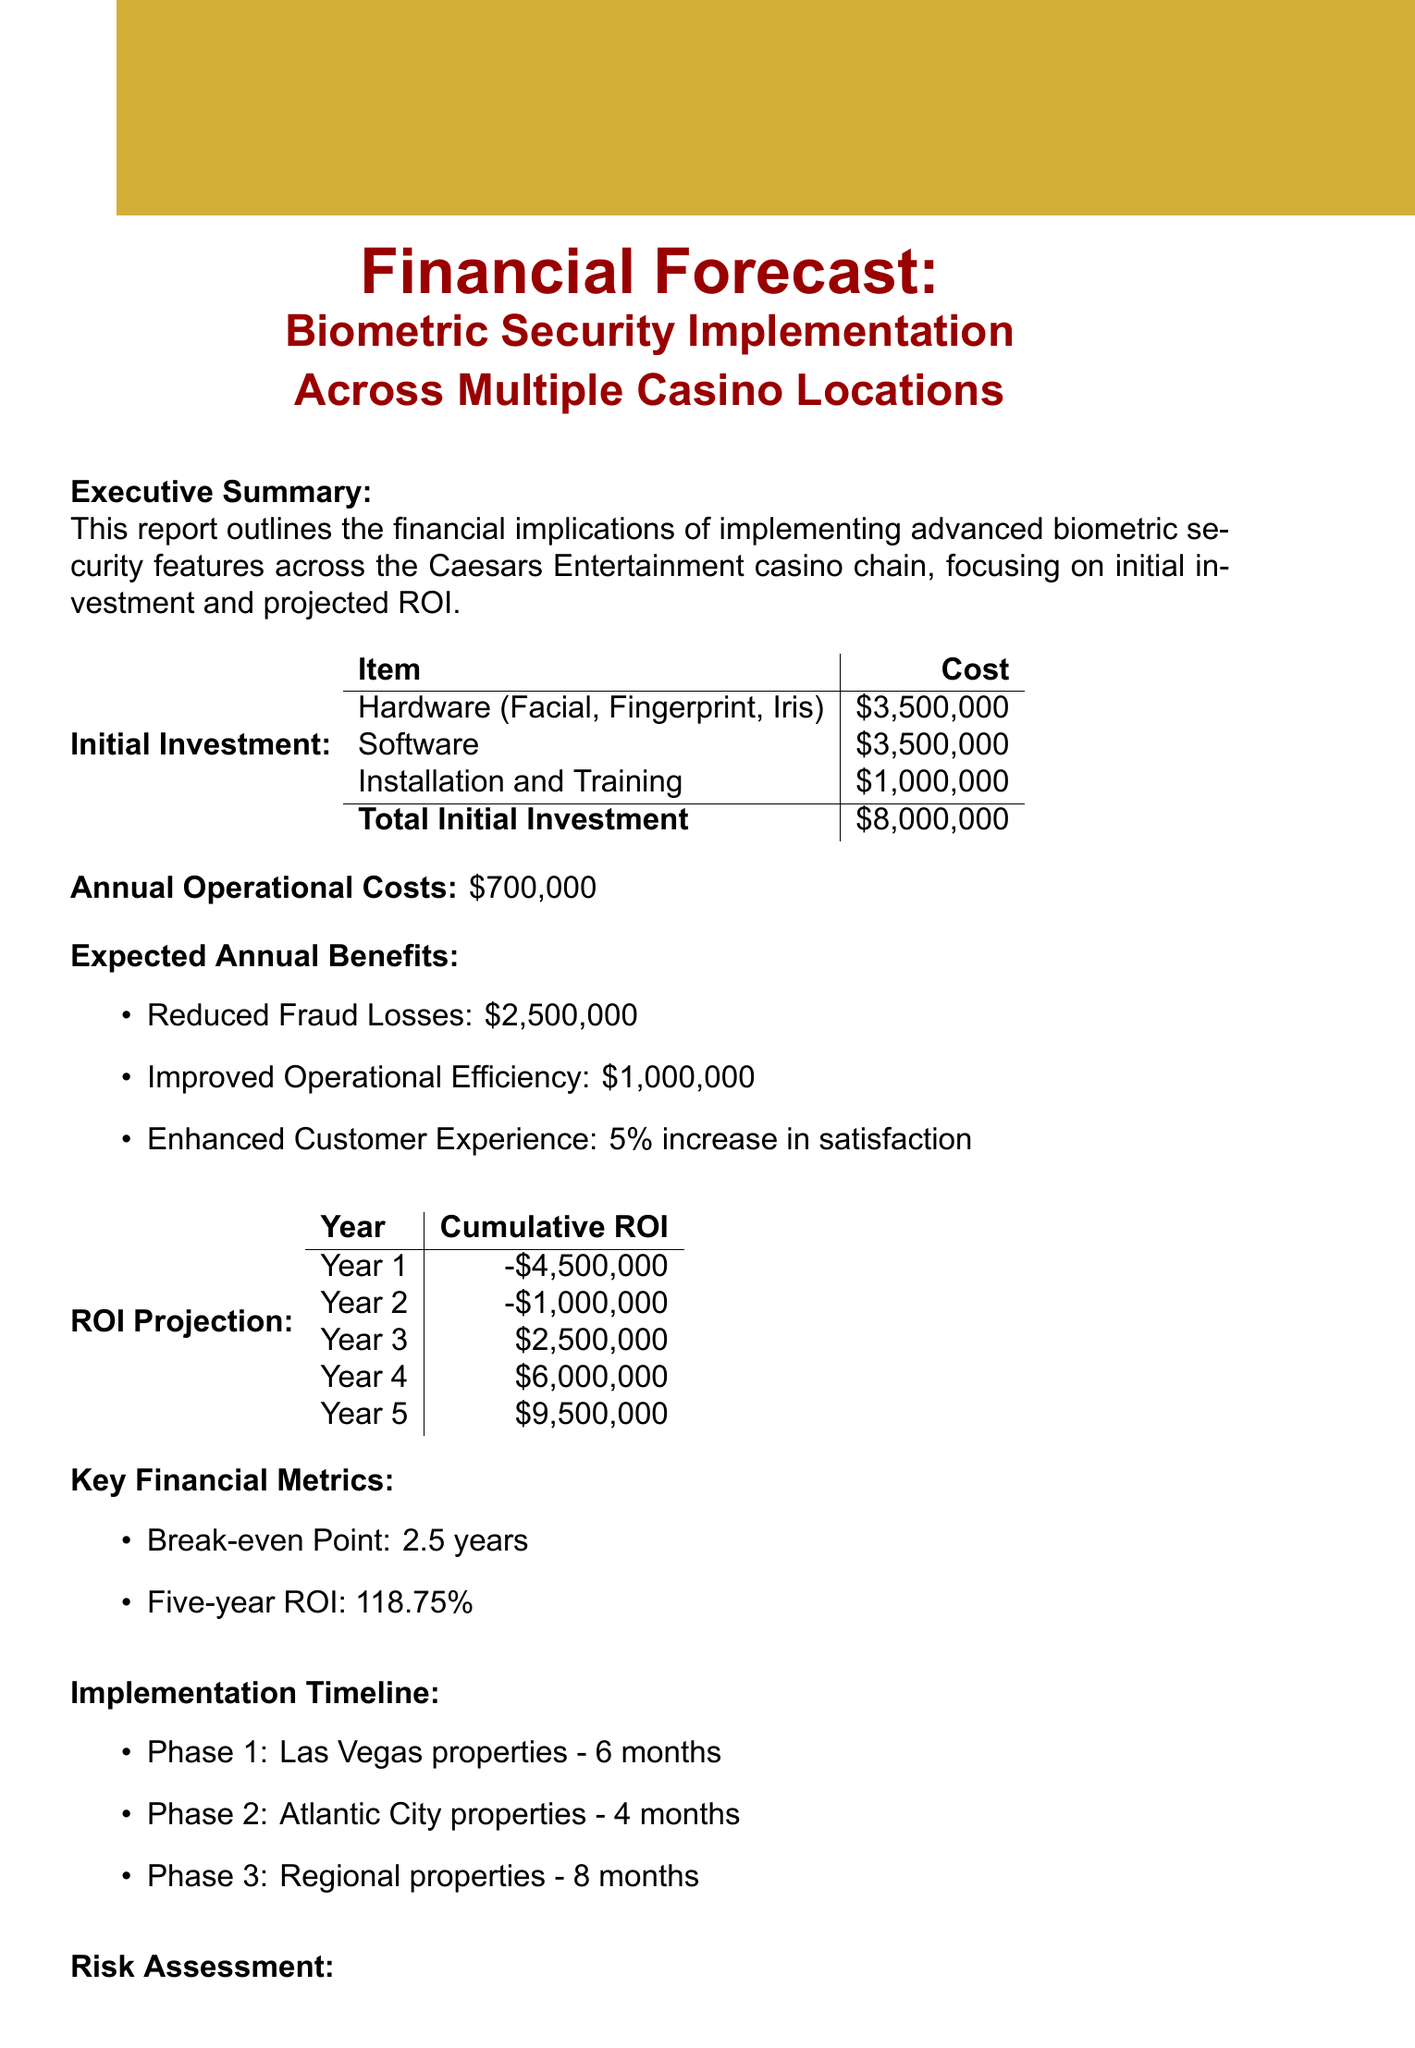what is the total initial investment? The total initial investment is calculated by summing up all costs, which totals to $8,000,000.
Answer: $8,000,000 how much is allocated for facial recognition cameras? The cost specifically allocated for facial recognition cameras is stated in the document as $1,200,000.
Answer: $1,200,000 what is the expected annual benefit from reduced fraud losses? The document indicates that the expected annual benefit from reduced fraud losses is $2,500,000.
Answer: $2,500,000 how long will the implementation take in Las Vegas properties? The timeline for implementation in Las Vegas properties is specified as 6 months.
Answer: 6 months what is the break-even point in years? The break-even point is mentioned in the report as 2.5 years.
Answer: 2.5 years which phase has the shortest implementation time? The shortest implementation time is for the Atlantic City properties, which is stated as 4 months.
Answer: 4 months what is the five-year ROI percentage? The five-year ROI is reported as 118.75%.
Answer: 118.75% is data security considered a high or low risk? The document describes data security as critical, indicating it has high importance and thus is considered a high risk.
Answer: High how many annual operational costs are outlined in the report? The total annual operational costs are outlined as $700,000 in the report.
Answer: $700,000 